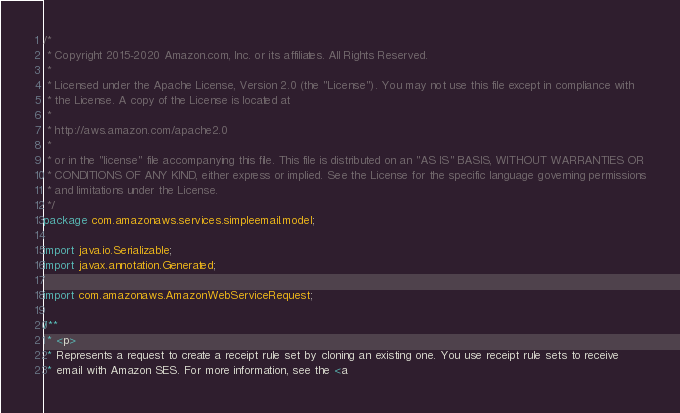<code> <loc_0><loc_0><loc_500><loc_500><_Java_>/*
 * Copyright 2015-2020 Amazon.com, Inc. or its affiliates. All Rights Reserved.
 * 
 * Licensed under the Apache License, Version 2.0 (the "License"). You may not use this file except in compliance with
 * the License. A copy of the License is located at
 * 
 * http://aws.amazon.com/apache2.0
 * 
 * or in the "license" file accompanying this file. This file is distributed on an "AS IS" BASIS, WITHOUT WARRANTIES OR
 * CONDITIONS OF ANY KIND, either express or implied. See the License for the specific language governing permissions
 * and limitations under the License.
 */
package com.amazonaws.services.simpleemail.model;

import java.io.Serializable;
import javax.annotation.Generated;

import com.amazonaws.AmazonWebServiceRequest;

/**
 * <p>
 * Represents a request to create a receipt rule set by cloning an existing one. You use receipt rule sets to receive
 * email with Amazon SES. For more information, see the <a</code> 